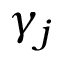<formula> <loc_0><loc_0><loc_500><loc_500>\gamma _ { j }</formula> 